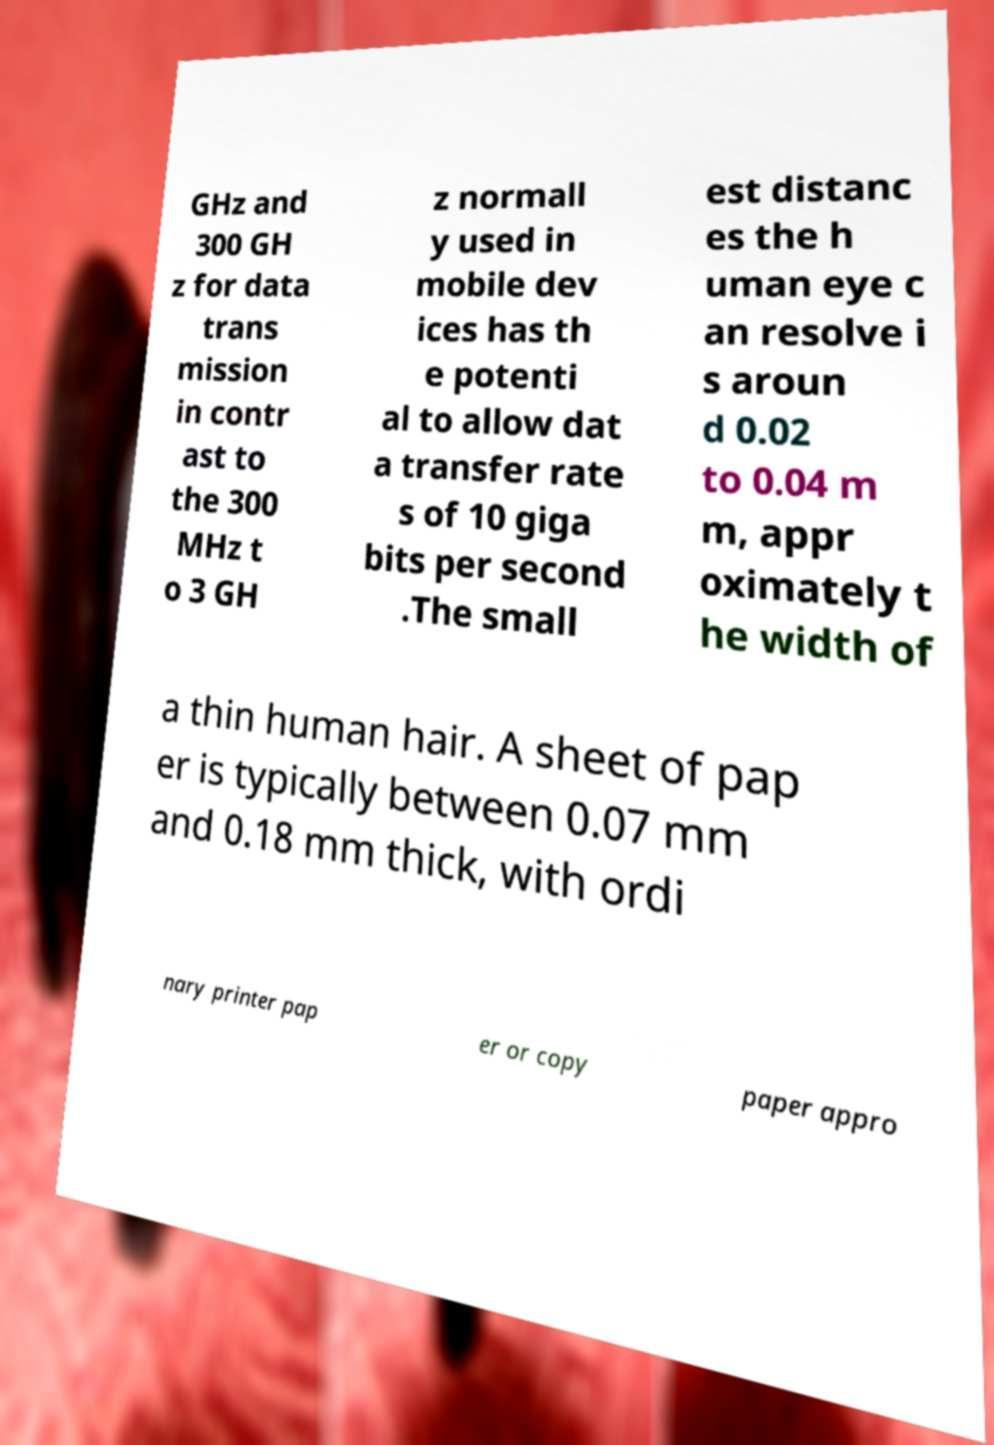Please identify and transcribe the text found in this image. GHz and 300 GH z for data trans mission in contr ast to the 300 MHz t o 3 GH z normall y used in mobile dev ices has th e potenti al to allow dat a transfer rate s of 10 giga bits per second .The small est distanc es the h uman eye c an resolve i s aroun d 0.02 to 0.04 m m, appr oximately t he width of a thin human hair. A sheet of pap er is typically between 0.07 mm and 0.18 mm thick, with ordi nary printer pap er or copy paper appro 